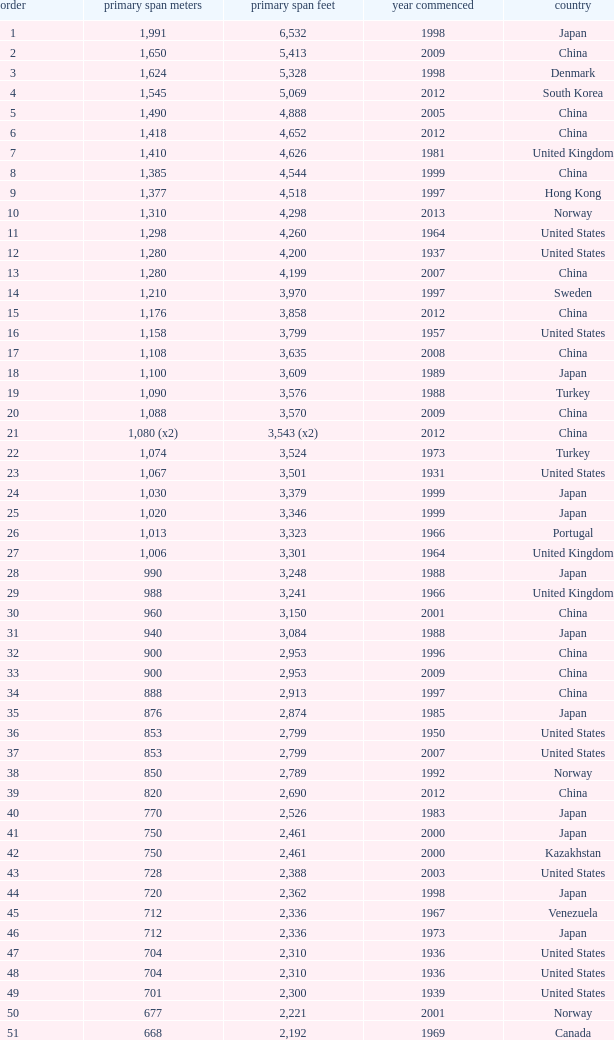What is the highest rank from the year greater than 2010 with 430 main span metres? 94.0. 